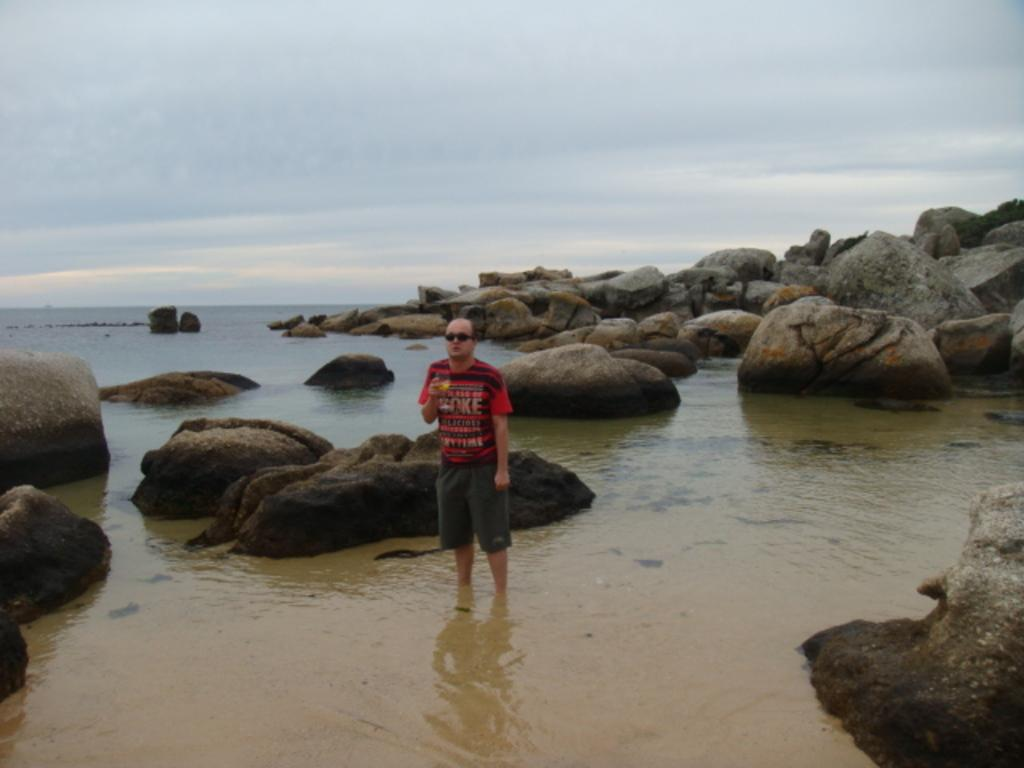What is the man in the image doing? The man is standing in the water. What else can be seen in the image besides the man? There are rocks visible in the image. What is visible in the background of the image? The sky is visible in the background of the image. What can be observed about the sky in the image? There are clouds in the sky. What type of party is being held on the rocks in the image? There is no party visible in the image; it only shows a man standing in the water and rocks. 